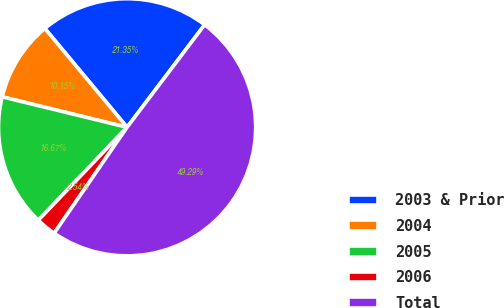<chart> <loc_0><loc_0><loc_500><loc_500><pie_chart><fcel>2003 & Prior<fcel>2004<fcel>2005<fcel>2006<fcel>Total<nl><fcel>21.35%<fcel>10.15%<fcel>16.67%<fcel>2.54%<fcel>49.29%<nl></chart> 